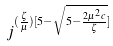Convert formula to latex. <formula><loc_0><loc_0><loc_500><loc_500>j ^ { ( \frac { \zeta } { \mu } ) [ 5 - \sqrt { 5 - \frac { 2 \mu ^ { 2 } c } { \zeta } } ] }</formula> 